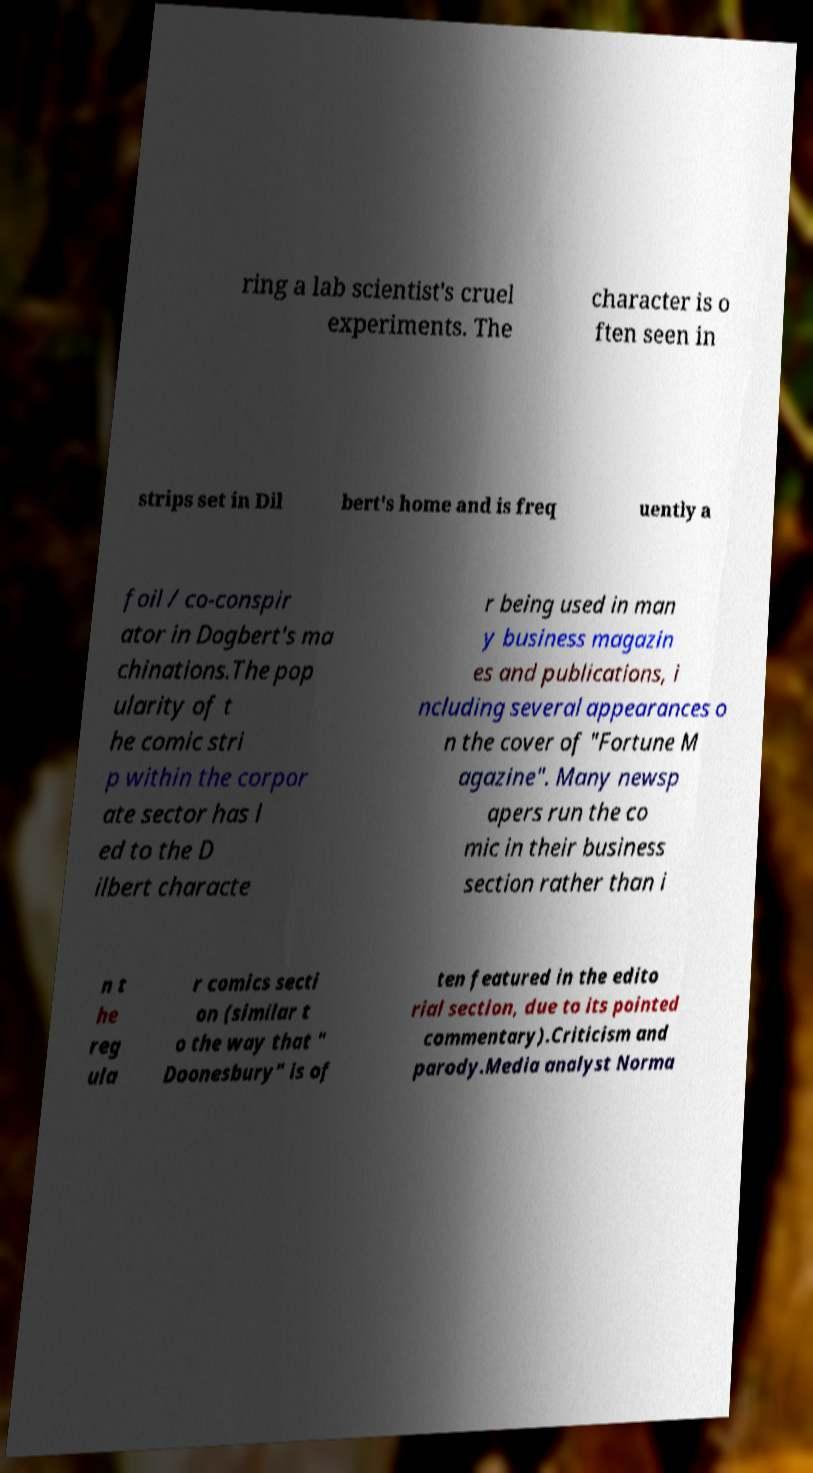Can you accurately transcribe the text from the provided image for me? ring a lab scientist's cruel experiments. The character is o ften seen in strips set in Dil bert's home and is freq uently a foil / co-conspir ator in Dogbert's ma chinations.The pop ularity of t he comic stri p within the corpor ate sector has l ed to the D ilbert characte r being used in man y business magazin es and publications, i ncluding several appearances o n the cover of "Fortune M agazine". Many newsp apers run the co mic in their business section rather than i n t he reg ula r comics secti on (similar t o the way that " Doonesbury" is of ten featured in the edito rial section, due to its pointed commentary).Criticism and parody.Media analyst Norma 